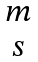Convert formula to latex. <formula><loc_0><loc_0><loc_500><loc_500>\begin{matrix} m \\ s \end{matrix}</formula> 